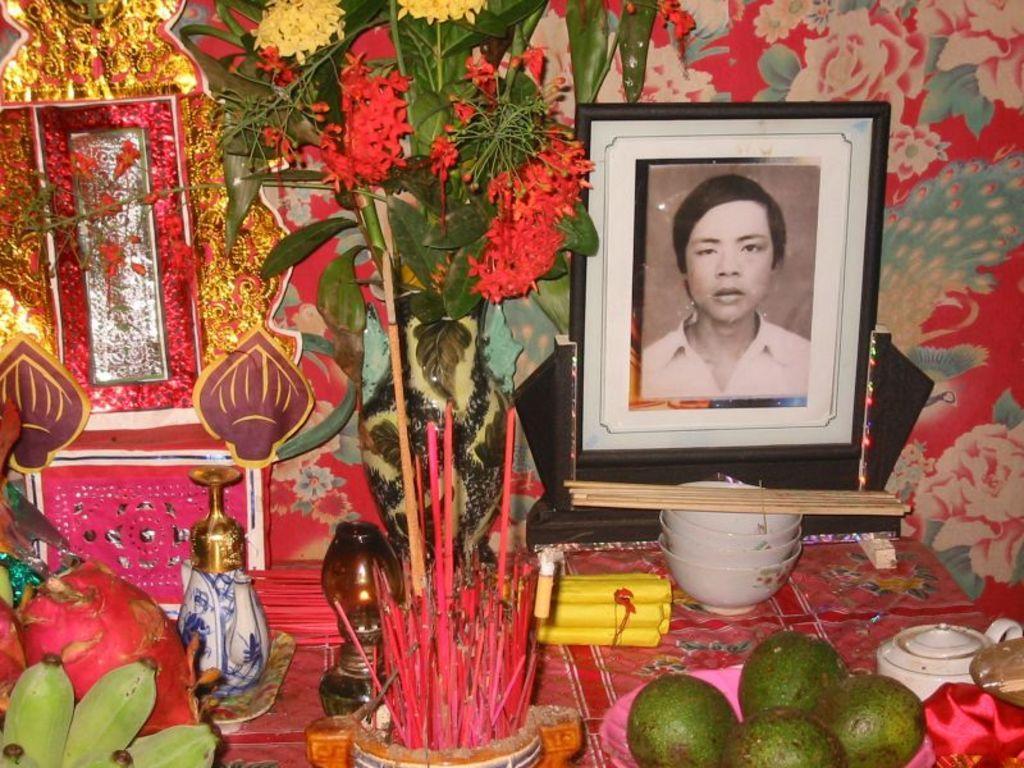Describe this image in one or two sentences. On the right side of the image we can see a frame, in front of the frame we can see few bowels, fruits, flowers and other things. 